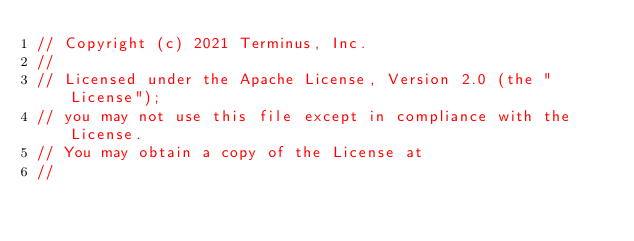Convert code to text. <code><loc_0><loc_0><loc_500><loc_500><_Go_>// Copyright (c) 2021 Terminus, Inc.
//
// Licensed under the Apache License, Version 2.0 (the "License");
// you may not use this file except in compliance with the License.
// You may obtain a copy of the License at
//</code> 